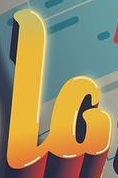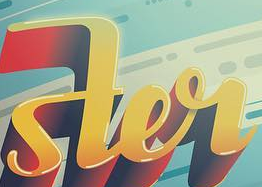Read the text content from these images in order, separated by a semicolon. la; ster 